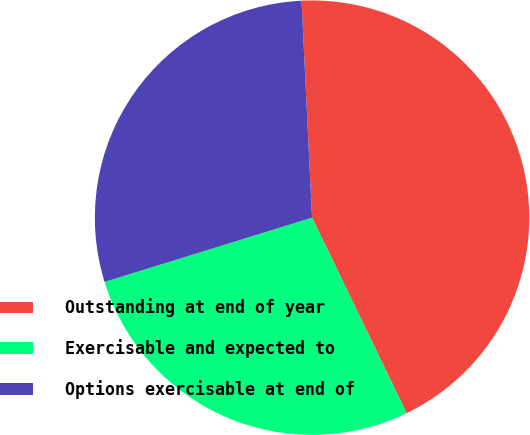Convert chart. <chart><loc_0><loc_0><loc_500><loc_500><pie_chart><fcel>Outstanding at end of year<fcel>Exercisable and expected to<fcel>Options exercisable at end of<nl><fcel>43.6%<fcel>27.39%<fcel>29.01%<nl></chart> 